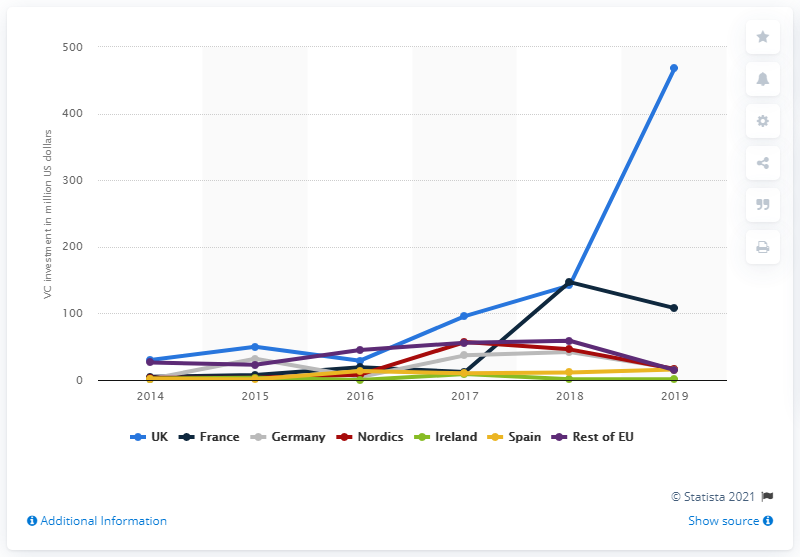Outline some significant characteristics in this image. In 2019, the UK invested a significant amount of venture capital. Specifically, the amount was 468. France is the leading country/region for venture capital investment in the European EdTech sector. 